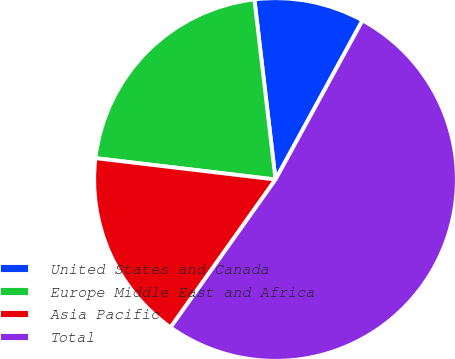Convert chart. <chart><loc_0><loc_0><loc_500><loc_500><pie_chart><fcel>United States and Canada<fcel>Europe Middle East and Africa<fcel>Asia Pacific<fcel>Total<nl><fcel>9.82%<fcel>21.26%<fcel>17.06%<fcel>51.86%<nl></chart> 